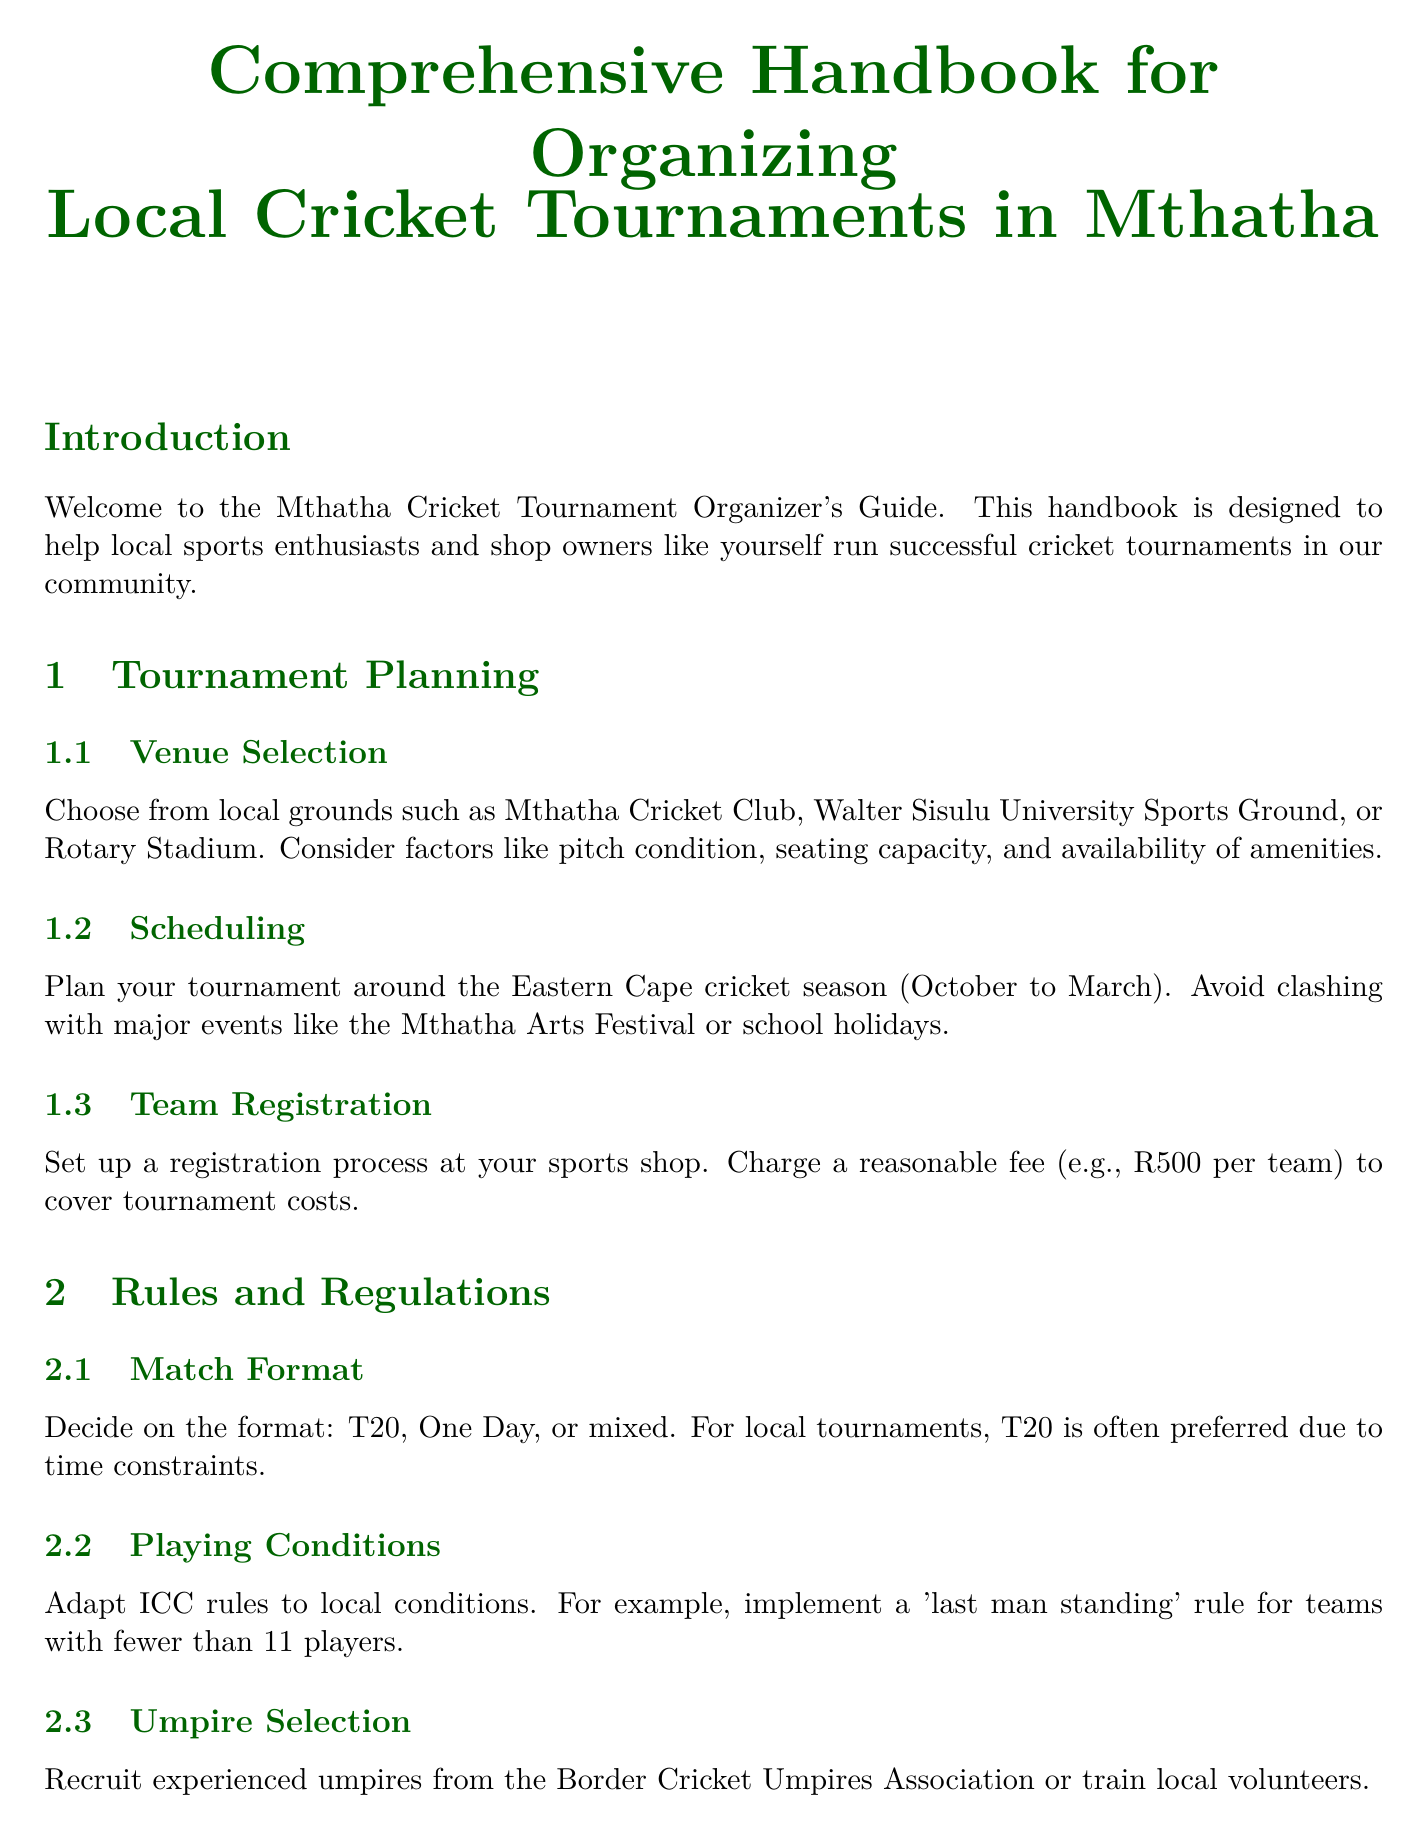What is the title of the handbook? The title of the handbook is provided in the document's title section.
Answer: Comprehensive Handbook for Organizing Local Cricket Tournaments in Mthatha Which venue is suggested for hosting matches? The document lists local grounds suitable for venue selection.
Answer: Mthatha Cricket Club What is the preferred match format for local tournaments? The document specifies the format that is often chosen for local tournaments.
Answer: T20 What is the team registration fee mentioned in the document? The document states a reasonable fee for team registration to cover costs.
Answer: R500 What age limit is set for senior tournaments? The document outlines the eligibility criteria, including age limits for participation.
Answer: 16+ Who should be approached for local media engagement? The document suggests specific local media outlets for coverage and announcements.
Answer: Unitra Community Radio What type of feedback is recommended to be collected post-tournament? The document mentions methods to gather insights for future improvements.
Answer: Survey Which local healthcare provider is suggested for injury management? The document recommends a specific hospital for on-site first aid and services.
Answer: Life St Mary's Private Hospital 